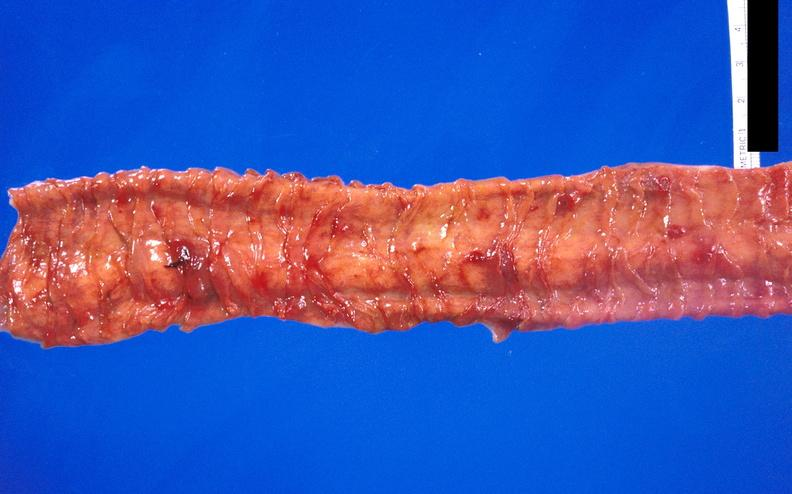where does this belong to?
Answer the question using a single word or phrase. Gastrointestinal system 